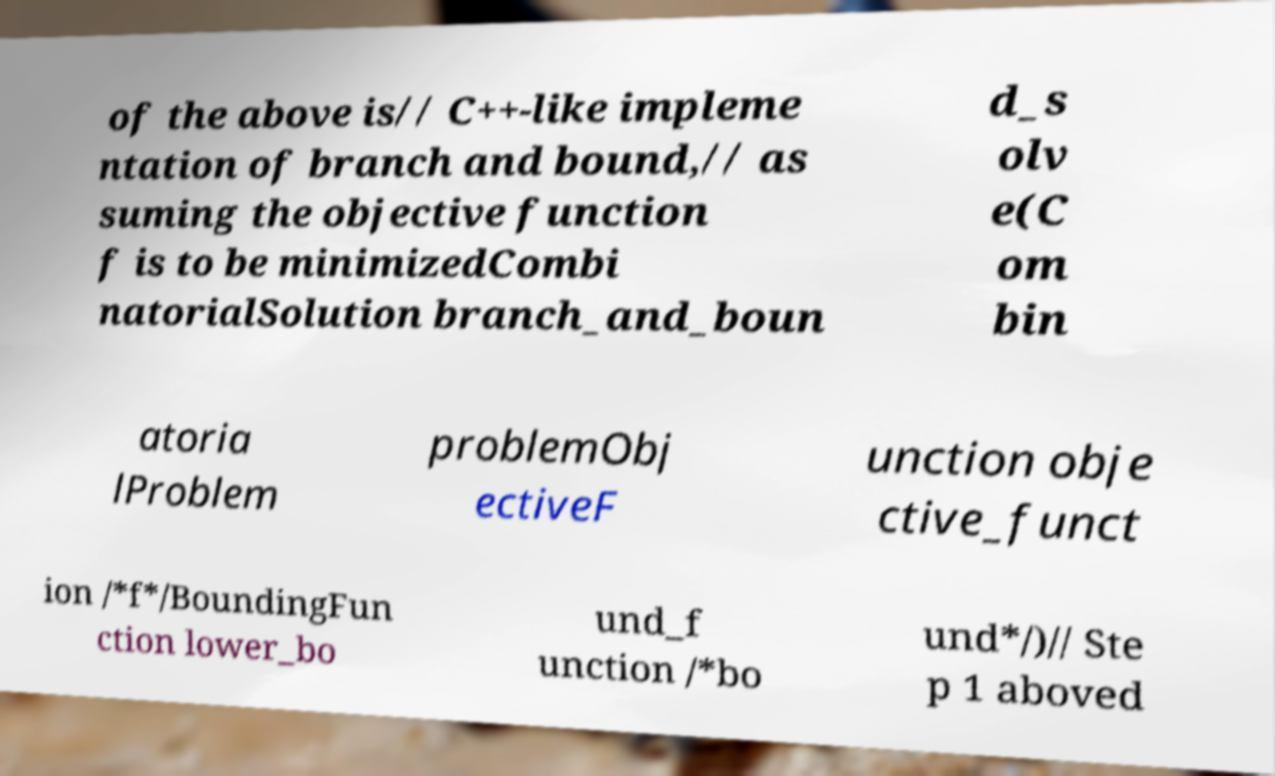Can you read and provide the text displayed in the image?This photo seems to have some interesting text. Can you extract and type it out for me? of the above is// C++-like impleme ntation of branch and bound,// as suming the objective function f is to be minimizedCombi natorialSolution branch_and_boun d_s olv e(C om bin atoria lProblem problemObj ectiveF unction obje ctive_funct ion /*f*/BoundingFun ction lower_bo und_f unction /*bo und*/)// Ste p 1 aboved 